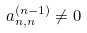<formula> <loc_0><loc_0><loc_500><loc_500>a _ { n , n } ^ { ( n - 1 ) } \ne 0</formula> 